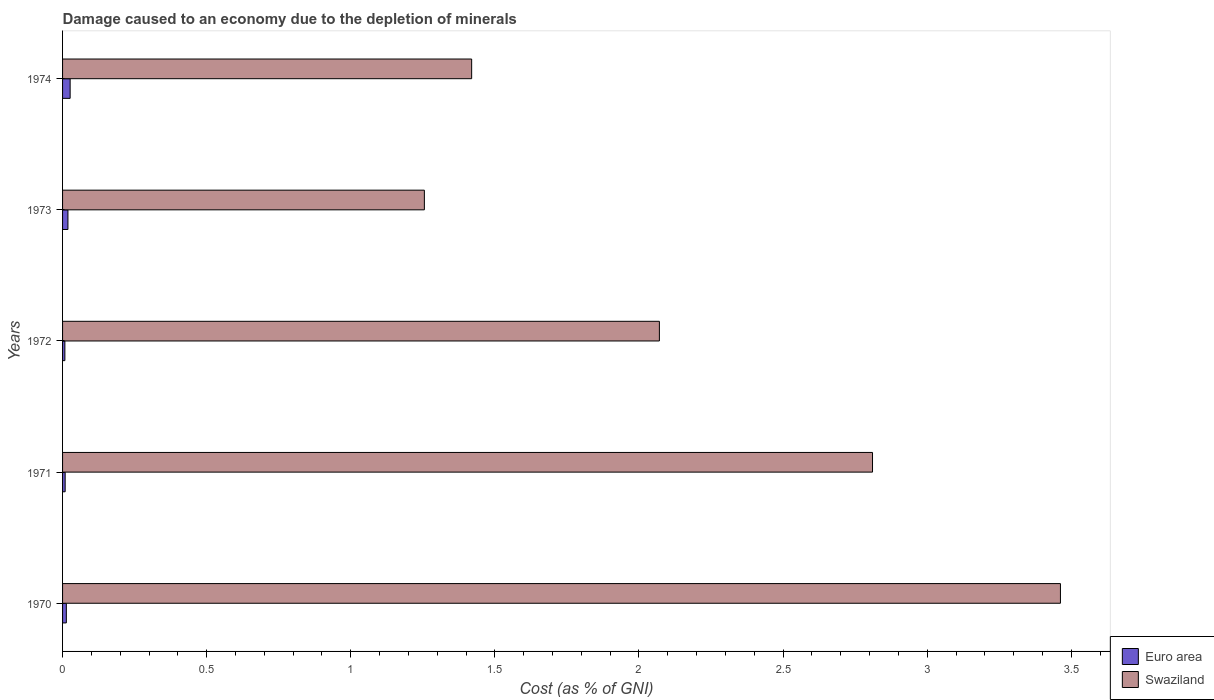How many different coloured bars are there?
Ensure brevity in your answer.  2. Are the number of bars per tick equal to the number of legend labels?
Give a very brief answer. Yes. Are the number of bars on each tick of the Y-axis equal?
Make the answer very short. Yes. How many bars are there on the 3rd tick from the top?
Provide a short and direct response. 2. What is the label of the 1st group of bars from the top?
Your response must be concise. 1974. What is the cost of damage caused due to the depletion of minerals in Swaziland in 1972?
Give a very brief answer. 2.07. Across all years, what is the maximum cost of damage caused due to the depletion of minerals in Swaziland?
Your answer should be compact. 3.46. Across all years, what is the minimum cost of damage caused due to the depletion of minerals in Swaziland?
Make the answer very short. 1.26. In which year was the cost of damage caused due to the depletion of minerals in Euro area minimum?
Make the answer very short. 1972. What is the total cost of damage caused due to the depletion of minerals in Euro area in the graph?
Keep it short and to the point. 0.08. What is the difference between the cost of damage caused due to the depletion of minerals in Euro area in 1972 and that in 1973?
Your answer should be very brief. -0.01. What is the difference between the cost of damage caused due to the depletion of minerals in Euro area in 1970 and the cost of damage caused due to the depletion of minerals in Swaziland in 1973?
Provide a succinct answer. -1.24. What is the average cost of damage caused due to the depletion of minerals in Euro area per year?
Your answer should be compact. 0.02. In the year 1972, what is the difference between the cost of damage caused due to the depletion of minerals in Swaziland and cost of damage caused due to the depletion of minerals in Euro area?
Ensure brevity in your answer.  2.06. In how many years, is the cost of damage caused due to the depletion of minerals in Euro area greater than 1.6 %?
Your answer should be compact. 0. What is the ratio of the cost of damage caused due to the depletion of minerals in Swaziland in 1970 to that in 1973?
Your answer should be compact. 2.76. Is the cost of damage caused due to the depletion of minerals in Swaziland in 1970 less than that in 1971?
Offer a very short reply. No. Is the difference between the cost of damage caused due to the depletion of minerals in Swaziland in 1972 and 1973 greater than the difference between the cost of damage caused due to the depletion of minerals in Euro area in 1972 and 1973?
Make the answer very short. Yes. What is the difference between the highest and the second highest cost of damage caused due to the depletion of minerals in Swaziland?
Provide a succinct answer. 0.65. What is the difference between the highest and the lowest cost of damage caused due to the depletion of minerals in Euro area?
Your answer should be compact. 0.02. What does the 1st bar from the top in 1972 represents?
Keep it short and to the point. Swaziland. How many bars are there?
Offer a terse response. 10. Are all the bars in the graph horizontal?
Offer a terse response. Yes. What is the difference between two consecutive major ticks on the X-axis?
Your answer should be very brief. 0.5. Does the graph contain grids?
Keep it short and to the point. No. Where does the legend appear in the graph?
Your answer should be compact. Bottom right. How many legend labels are there?
Give a very brief answer. 2. How are the legend labels stacked?
Offer a very short reply. Vertical. What is the title of the graph?
Your answer should be very brief. Damage caused to an economy due to the depletion of minerals. What is the label or title of the X-axis?
Give a very brief answer. Cost (as % of GNI). What is the Cost (as % of GNI) of Euro area in 1970?
Ensure brevity in your answer.  0.01. What is the Cost (as % of GNI) of Swaziland in 1970?
Your answer should be very brief. 3.46. What is the Cost (as % of GNI) in Euro area in 1971?
Keep it short and to the point. 0.01. What is the Cost (as % of GNI) in Swaziland in 1971?
Ensure brevity in your answer.  2.81. What is the Cost (as % of GNI) in Euro area in 1972?
Keep it short and to the point. 0.01. What is the Cost (as % of GNI) of Swaziland in 1972?
Your response must be concise. 2.07. What is the Cost (as % of GNI) in Euro area in 1973?
Your answer should be compact. 0.02. What is the Cost (as % of GNI) of Swaziland in 1973?
Ensure brevity in your answer.  1.26. What is the Cost (as % of GNI) in Euro area in 1974?
Provide a short and direct response. 0.03. What is the Cost (as % of GNI) of Swaziland in 1974?
Your answer should be compact. 1.42. Across all years, what is the maximum Cost (as % of GNI) of Euro area?
Ensure brevity in your answer.  0.03. Across all years, what is the maximum Cost (as % of GNI) of Swaziland?
Provide a succinct answer. 3.46. Across all years, what is the minimum Cost (as % of GNI) in Euro area?
Provide a short and direct response. 0.01. Across all years, what is the minimum Cost (as % of GNI) of Swaziland?
Provide a short and direct response. 1.26. What is the total Cost (as % of GNI) in Euro area in the graph?
Offer a terse response. 0.08. What is the total Cost (as % of GNI) of Swaziland in the graph?
Provide a succinct answer. 11.02. What is the difference between the Cost (as % of GNI) in Euro area in 1970 and that in 1971?
Offer a very short reply. 0. What is the difference between the Cost (as % of GNI) of Swaziland in 1970 and that in 1971?
Keep it short and to the point. 0.65. What is the difference between the Cost (as % of GNI) in Euro area in 1970 and that in 1972?
Give a very brief answer. 0.01. What is the difference between the Cost (as % of GNI) in Swaziland in 1970 and that in 1972?
Make the answer very short. 1.39. What is the difference between the Cost (as % of GNI) of Euro area in 1970 and that in 1973?
Your answer should be very brief. -0.01. What is the difference between the Cost (as % of GNI) of Swaziland in 1970 and that in 1973?
Give a very brief answer. 2.21. What is the difference between the Cost (as % of GNI) of Euro area in 1970 and that in 1974?
Your answer should be very brief. -0.01. What is the difference between the Cost (as % of GNI) of Swaziland in 1970 and that in 1974?
Ensure brevity in your answer.  2.04. What is the difference between the Cost (as % of GNI) of Swaziland in 1971 and that in 1972?
Your response must be concise. 0.74. What is the difference between the Cost (as % of GNI) of Euro area in 1971 and that in 1973?
Ensure brevity in your answer.  -0.01. What is the difference between the Cost (as % of GNI) of Swaziland in 1971 and that in 1973?
Your answer should be compact. 1.55. What is the difference between the Cost (as % of GNI) in Euro area in 1971 and that in 1974?
Keep it short and to the point. -0.02. What is the difference between the Cost (as % of GNI) in Swaziland in 1971 and that in 1974?
Your response must be concise. 1.39. What is the difference between the Cost (as % of GNI) in Euro area in 1972 and that in 1973?
Keep it short and to the point. -0.01. What is the difference between the Cost (as % of GNI) in Swaziland in 1972 and that in 1973?
Offer a terse response. 0.82. What is the difference between the Cost (as % of GNI) in Euro area in 1972 and that in 1974?
Provide a short and direct response. -0.02. What is the difference between the Cost (as % of GNI) in Swaziland in 1972 and that in 1974?
Provide a short and direct response. 0.65. What is the difference between the Cost (as % of GNI) in Euro area in 1973 and that in 1974?
Your answer should be compact. -0.01. What is the difference between the Cost (as % of GNI) of Swaziland in 1973 and that in 1974?
Ensure brevity in your answer.  -0.16. What is the difference between the Cost (as % of GNI) in Euro area in 1970 and the Cost (as % of GNI) in Swaziland in 1971?
Give a very brief answer. -2.8. What is the difference between the Cost (as % of GNI) of Euro area in 1970 and the Cost (as % of GNI) of Swaziland in 1972?
Provide a succinct answer. -2.06. What is the difference between the Cost (as % of GNI) of Euro area in 1970 and the Cost (as % of GNI) of Swaziland in 1973?
Your answer should be compact. -1.24. What is the difference between the Cost (as % of GNI) of Euro area in 1970 and the Cost (as % of GNI) of Swaziland in 1974?
Provide a succinct answer. -1.41. What is the difference between the Cost (as % of GNI) of Euro area in 1971 and the Cost (as % of GNI) of Swaziland in 1972?
Provide a succinct answer. -2.06. What is the difference between the Cost (as % of GNI) of Euro area in 1971 and the Cost (as % of GNI) of Swaziland in 1973?
Give a very brief answer. -1.25. What is the difference between the Cost (as % of GNI) of Euro area in 1971 and the Cost (as % of GNI) of Swaziland in 1974?
Offer a very short reply. -1.41. What is the difference between the Cost (as % of GNI) in Euro area in 1972 and the Cost (as % of GNI) in Swaziland in 1973?
Provide a succinct answer. -1.25. What is the difference between the Cost (as % of GNI) of Euro area in 1972 and the Cost (as % of GNI) of Swaziland in 1974?
Give a very brief answer. -1.41. What is the difference between the Cost (as % of GNI) of Euro area in 1973 and the Cost (as % of GNI) of Swaziland in 1974?
Make the answer very short. -1.4. What is the average Cost (as % of GNI) in Euro area per year?
Your response must be concise. 0.01. What is the average Cost (as % of GNI) in Swaziland per year?
Give a very brief answer. 2.2. In the year 1970, what is the difference between the Cost (as % of GNI) of Euro area and Cost (as % of GNI) of Swaziland?
Your answer should be very brief. -3.45. In the year 1971, what is the difference between the Cost (as % of GNI) in Euro area and Cost (as % of GNI) in Swaziland?
Make the answer very short. -2.8. In the year 1972, what is the difference between the Cost (as % of GNI) in Euro area and Cost (as % of GNI) in Swaziland?
Provide a short and direct response. -2.06. In the year 1973, what is the difference between the Cost (as % of GNI) of Euro area and Cost (as % of GNI) of Swaziland?
Provide a succinct answer. -1.24. In the year 1974, what is the difference between the Cost (as % of GNI) in Euro area and Cost (as % of GNI) in Swaziland?
Your answer should be compact. -1.39. What is the ratio of the Cost (as % of GNI) in Euro area in 1970 to that in 1971?
Provide a short and direct response. 1.45. What is the ratio of the Cost (as % of GNI) of Swaziland in 1970 to that in 1971?
Give a very brief answer. 1.23. What is the ratio of the Cost (as % of GNI) in Euro area in 1970 to that in 1972?
Your answer should be very brief. 1.63. What is the ratio of the Cost (as % of GNI) of Swaziland in 1970 to that in 1972?
Keep it short and to the point. 1.67. What is the ratio of the Cost (as % of GNI) in Euro area in 1970 to that in 1973?
Your answer should be compact. 0.7. What is the ratio of the Cost (as % of GNI) of Swaziland in 1970 to that in 1973?
Your response must be concise. 2.76. What is the ratio of the Cost (as % of GNI) of Euro area in 1970 to that in 1974?
Your answer should be compact. 0.5. What is the ratio of the Cost (as % of GNI) in Swaziland in 1970 to that in 1974?
Offer a terse response. 2.44. What is the ratio of the Cost (as % of GNI) in Euro area in 1971 to that in 1972?
Provide a short and direct response. 1.12. What is the ratio of the Cost (as % of GNI) of Swaziland in 1971 to that in 1972?
Make the answer very short. 1.36. What is the ratio of the Cost (as % of GNI) of Euro area in 1971 to that in 1973?
Provide a short and direct response. 0.48. What is the ratio of the Cost (as % of GNI) of Swaziland in 1971 to that in 1973?
Your response must be concise. 2.24. What is the ratio of the Cost (as % of GNI) in Euro area in 1971 to that in 1974?
Provide a succinct answer. 0.34. What is the ratio of the Cost (as % of GNI) in Swaziland in 1971 to that in 1974?
Provide a succinct answer. 1.98. What is the ratio of the Cost (as % of GNI) in Euro area in 1972 to that in 1973?
Your answer should be compact. 0.43. What is the ratio of the Cost (as % of GNI) of Swaziland in 1972 to that in 1973?
Make the answer very short. 1.65. What is the ratio of the Cost (as % of GNI) of Euro area in 1972 to that in 1974?
Offer a terse response. 0.31. What is the ratio of the Cost (as % of GNI) in Swaziland in 1972 to that in 1974?
Your response must be concise. 1.46. What is the ratio of the Cost (as % of GNI) of Euro area in 1973 to that in 1974?
Provide a succinct answer. 0.71. What is the ratio of the Cost (as % of GNI) in Swaziland in 1973 to that in 1974?
Your response must be concise. 0.88. What is the difference between the highest and the second highest Cost (as % of GNI) in Euro area?
Your answer should be very brief. 0.01. What is the difference between the highest and the second highest Cost (as % of GNI) in Swaziland?
Your response must be concise. 0.65. What is the difference between the highest and the lowest Cost (as % of GNI) of Euro area?
Your response must be concise. 0.02. What is the difference between the highest and the lowest Cost (as % of GNI) in Swaziland?
Provide a succinct answer. 2.21. 